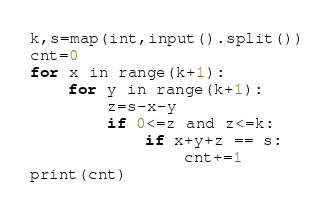Convert code to text. <code><loc_0><loc_0><loc_500><loc_500><_Python_>k,s=map(int,input().split())
cnt=0
for x in range(k+1):
    for y in range(k+1):
        z=s-x-y
        if 0<=z and z<=k:
            if x+y+z == s:
                cnt+=1
print(cnt)</code> 